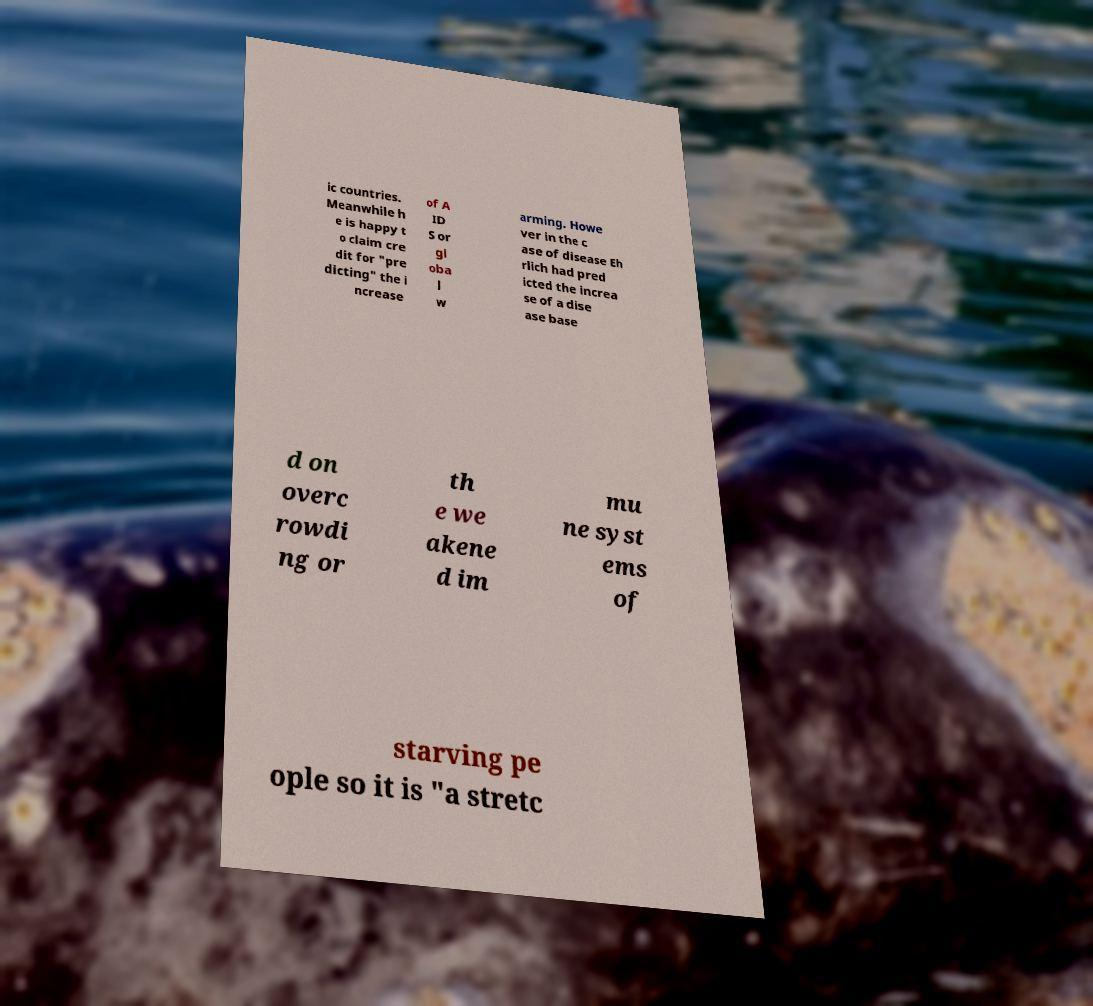For documentation purposes, I need the text within this image transcribed. Could you provide that? ic countries. Meanwhile h e is happy t o claim cre dit for "pre dicting" the i ncrease of A ID S or gl oba l w arming. Howe ver in the c ase of disease Eh rlich had pred icted the increa se of a dise ase base d on overc rowdi ng or th e we akene d im mu ne syst ems of starving pe ople so it is "a stretc 